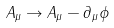Convert formula to latex. <formula><loc_0><loc_0><loc_500><loc_500>A _ { \mu } \rightarrow A _ { \mu } - \partial _ { \mu } \phi</formula> 